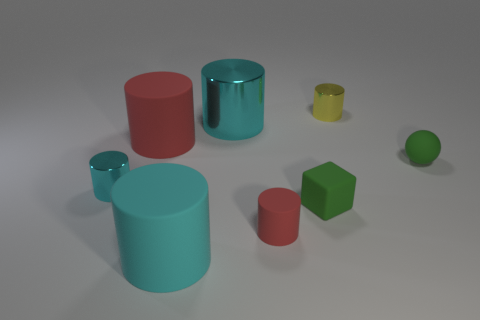Subtract all green blocks. How many cyan cylinders are left? 3 Subtract all yellow cylinders. How many cylinders are left? 5 Subtract all yellow cylinders. How many cylinders are left? 5 Subtract all yellow balls. Subtract all brown cylinders. How many balls are left? 1 Add 1 small rubber cubes. How many objects exist? 9 Subtract all spheres. How many objects are left? 7 Add 8 small red objects. How many small red objects are left? 9 Add 3 small rubber spheres. How many small rubber spheres exist? 4 Subtract 1 green blocks. How many objects are left? 7 Subtract all tiny green spheres. Subtract all balls. How many objects are left? 6 